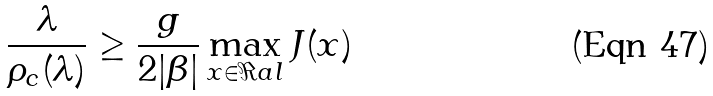<formula> <loc_0><loc_0><loc_500><loc_500>\frac { \lambda } { \rho _ { c } ( \lambda ) } \geq \frac { g } { 2 | \beta | } \max _ { x \in \Re a l } { J ( x ) }</formula> 